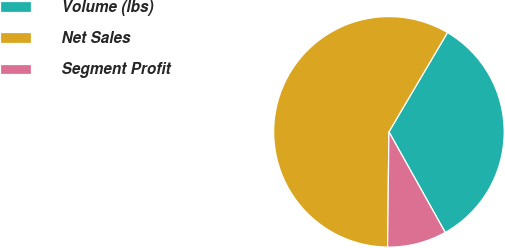<chart> <loc_0><loc_0><loc_500><loc_500><pie_chart><fcel>Volume (lbs)<fcel>Net Sales<fcel>Segment Profit<nl><fcel>33.4%<fcel>58.3%<fcel>8.3%<nl></chart> 